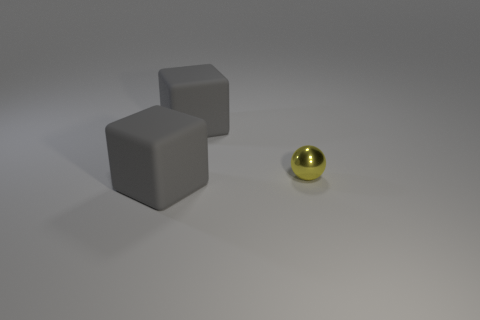Are there any big gray things on the left side of the metallic ball?
Provide a short and direct response. Yes. What number of things are large matte things in front of the small yellow shiny thing or matte things?
Make the answer very short. 2. There is a cube that is behind the small shiny object; how many big cubes are behind it?
Your response must be concise. 0. There is a large thing to the left of the gray object that is behind the sphere; what is its shape?
Your answer should be compact. Cube. What number of other things are there of the same material as the small sphere
Offer a very short reply. 0. Is there any other thing that is the same size as the metal object?
Give a very brief answer. No. Is the number of metallic balls greater than the number of large gray rubber objects?
Your response must be concise. No. What is the size of the block right of the matte cube on the left side of the large gray thing behind the tiny yellow object?
Offer a very short reply. Large. Does the ball have the same size as the gray matte cube in front of the small yellow shiny sphere?
Keep it short and to the point. No. Is the number of spheres that are behind the tiny metallic ball less than the number of tiny yellow metal balls?
Provide a succinct answer. Yes. 